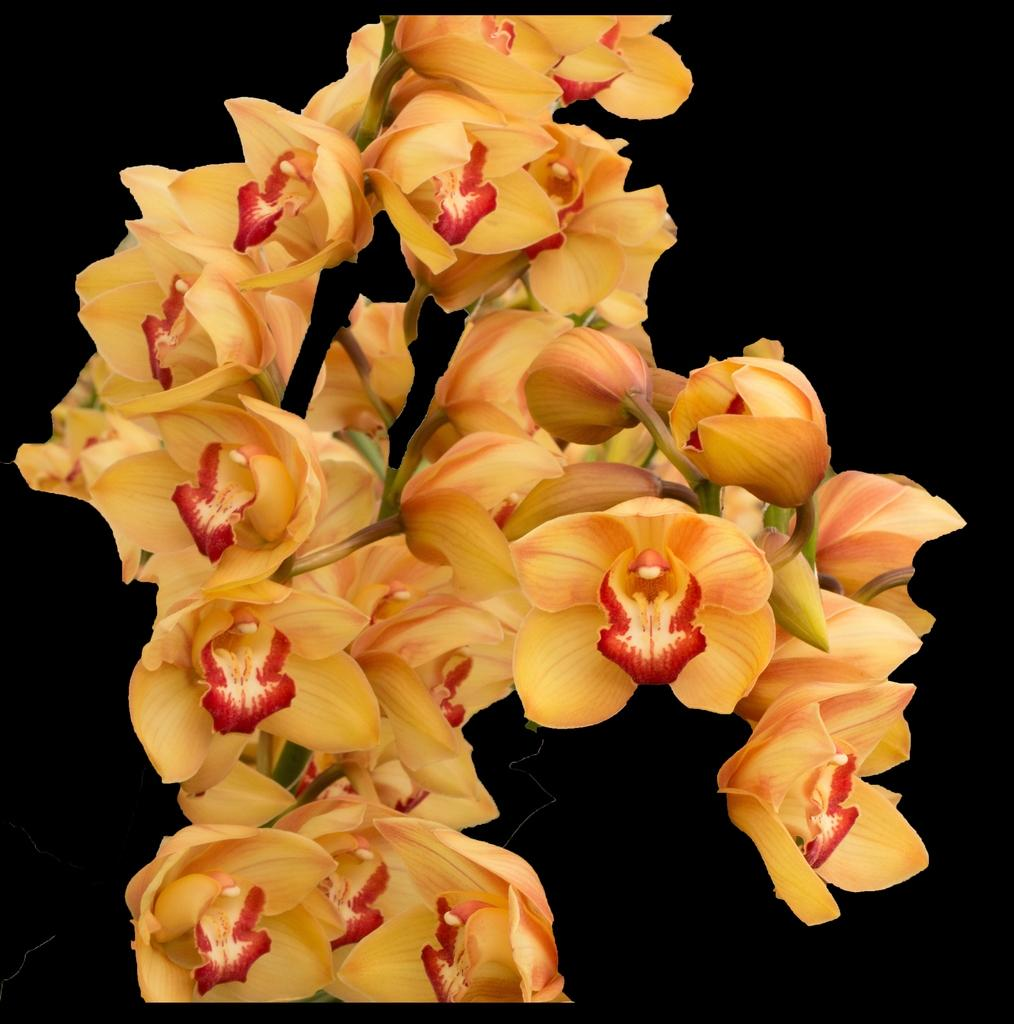What type of living organisms can be seen in the image? There are flowers in the image. What color is the background of the image? The background of the image is black. What type of fan is visible in the image? There is no fan present in the image. What type of rose can be seen in the image? There is no specific type of rose mentioned or visible in the image; it only shows flowers in general. 